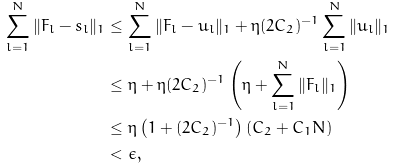Convert formula to latex. <formula><loc_0><loc_0><loc_500><loc_500>\sum _ { l = 1 } ^ { N } \| F _ { l } - s _ { l } \| _ { 1 } & \leq \sum _ { l = 1 } ^ { N } \| F _ { l } - u _ { l } \| _ { 1 } + \eta ( 2 C _ { 2 } ) ^ { - 1 } \sum _ { l = 1 } ^ { N } \| u _ { l } \| _ { 1 } \\ & \leq \eta + \eta ( 2 C _ { 2 } ) ^ { - 1 } \left ( \eta + \sum _ { l = 1 } ^ { N } \| F _ { l } \| _ { 1 } \right ) \\ & \leq \eta \left ( 1 + ( 2 C _ { 2 } ) ^ { - 1 } \right ) ( C _ { 2 } + C _ { 1 } N ) \\ & < \epsilon ,</formula> 